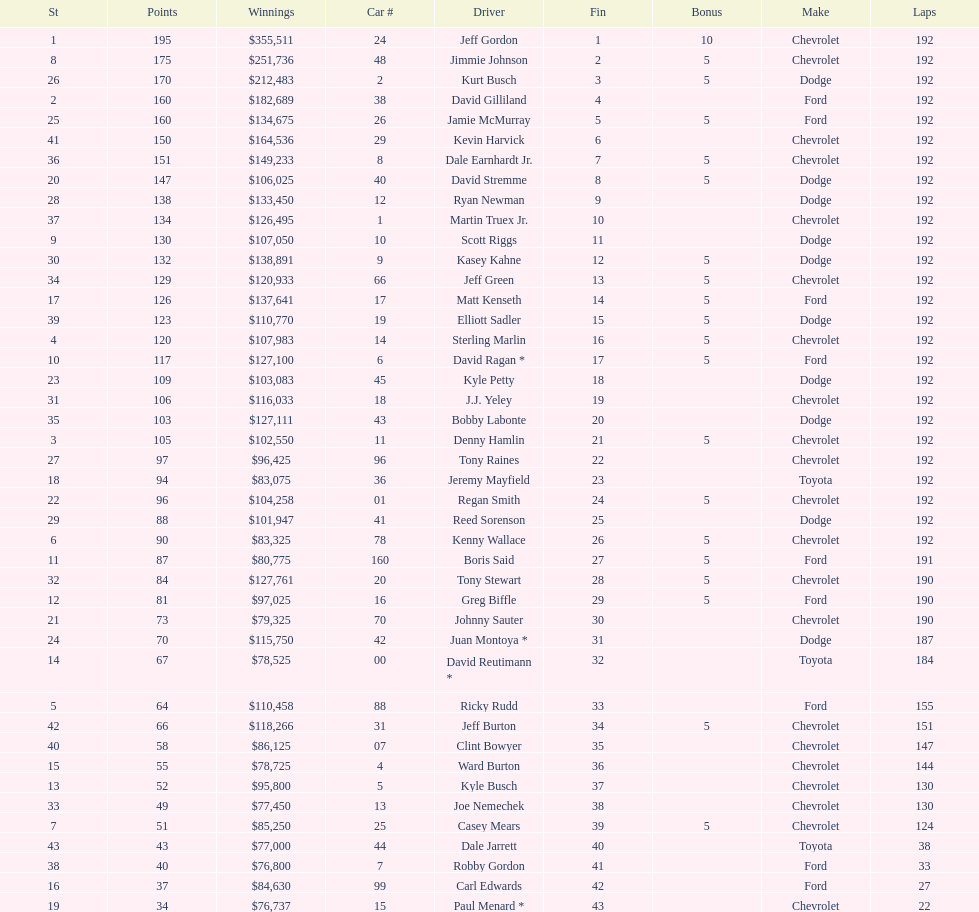What was jimmie johnson's winnings? $251,736. 